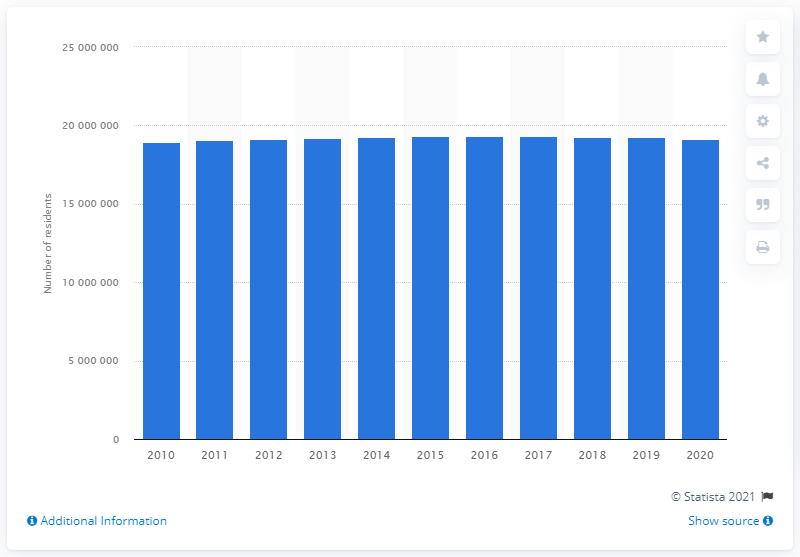Highlight a few significant elements in this photo. The population of the New York-Newark-Jersey City metropolitan area in 2010 was 18,923,437. In 2020, the New York-Newark-Jersey City metropolitan area was home to an estimated 19,053,124 people. 